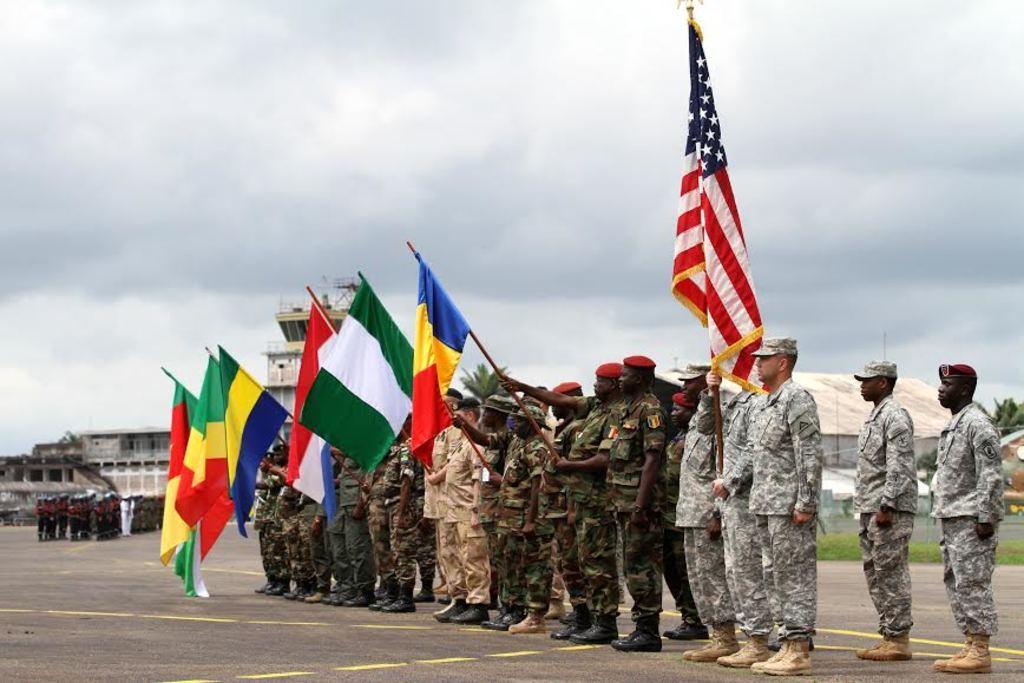Please provide a concise description of this image. In this image there are people standing on a road, few are holding flags in their hands, in the background there are people standing and there are buildings, trees and the sky. 